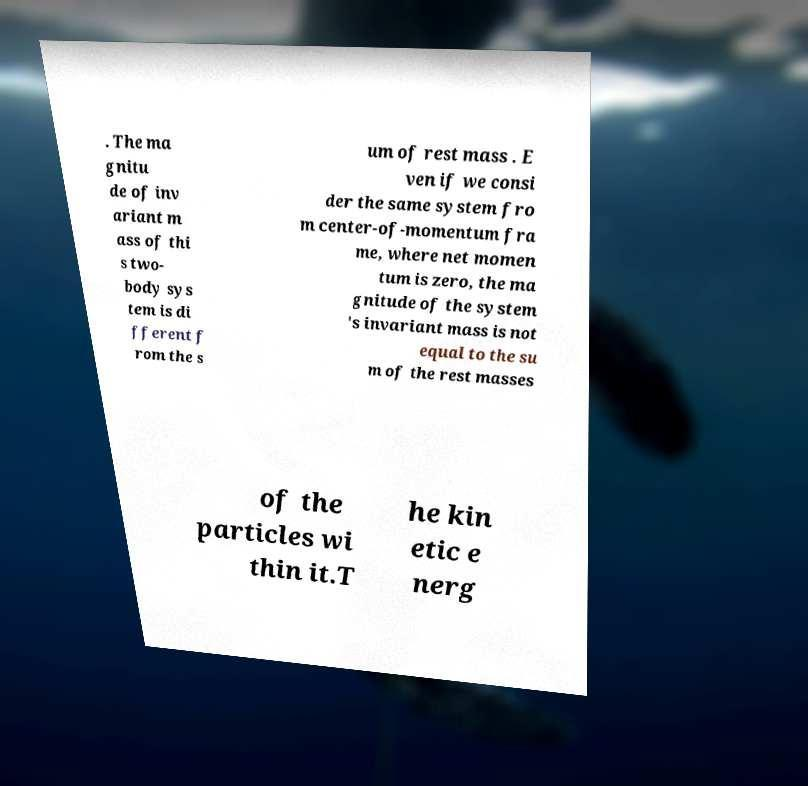Can you accurately transcribe the text from the provided image for me? . The ma gnitu de of inv ariant m ass of thi s two- body sys tem is di fferent f rom the s um of rest mass . E ven if we consi der the same system fro m center-of-momentum fra me, where net momen tum is zero, the ma gnitude of the system 's invariant mass is not equal to the su m of the rest masses of the particles wi thin it.T he kin etic e nerg 